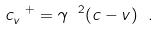Convert formula to latex. <formula><loc_0><loc_0><loc_500><loc_500>c _ { v } ^ { \ + } = \gamma ^ { \ 2 } ( c - v ) \ .</formula> 